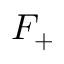<formula> <loc_0><loc_0><loc_500><loc_500>F _ { + }</formula> 